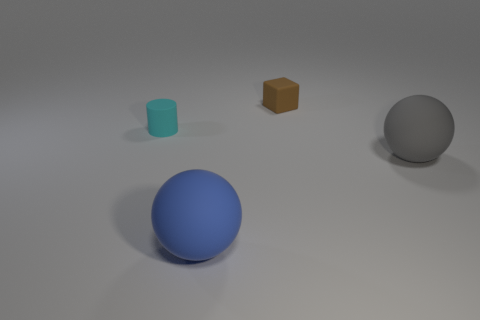Is the cyan cylinder made of the same material as the brown thing?
Ensure brevity in your answer.  Yes. Is there a small matte object of the same color as the rubber cylinder?
Your response must be concise. No. There is a brown thing that is the same material as the cyan thing; what size is it?
Give a very brief answer. Small. What is the shape of the big rubber object that is in front of the rubber ball behind the large matte thing in front of the large gray ball?
Keep it short and to the point. Sphere. There is another thing that is the same shape as the blue thing; what size is it?
Keep it short and to the point. Large. There is a thing that is on the left side of the small brown rubber thing and behind the blue matte thing; how big is it?
Your answer should be compact. Small. The matte cylinder has what color?
Provide a short and direct response. Cyan. What is the size of the matte object that is behind the small matte cylinder?
Keep it short and to the point. Small. There is a big matte ball to the right of the large matte object to the left of the gray rubber thing; how many brown rubber objects are behind it?
Your response must be concise. 1. There is a big ball behind the large ball to the left of the gray rubber sphere; what is its color?
Provide a succinct answer. Gray. 